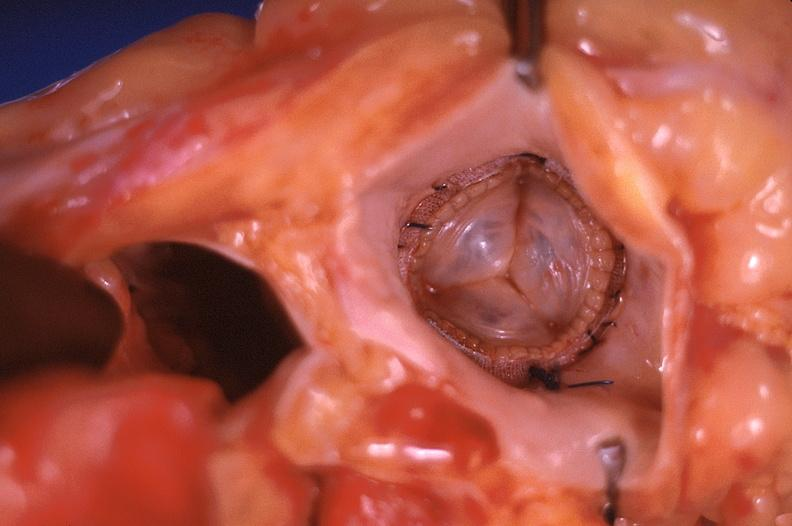what does this image show?
Answer the question using a single word or phrase. Prosthetic mitral valve 